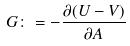<formula> <loc_0><loc_0><loc_500><loc_500>G \colon = - \frac { \partial ( U - V ) } { \partial A }</formula> 